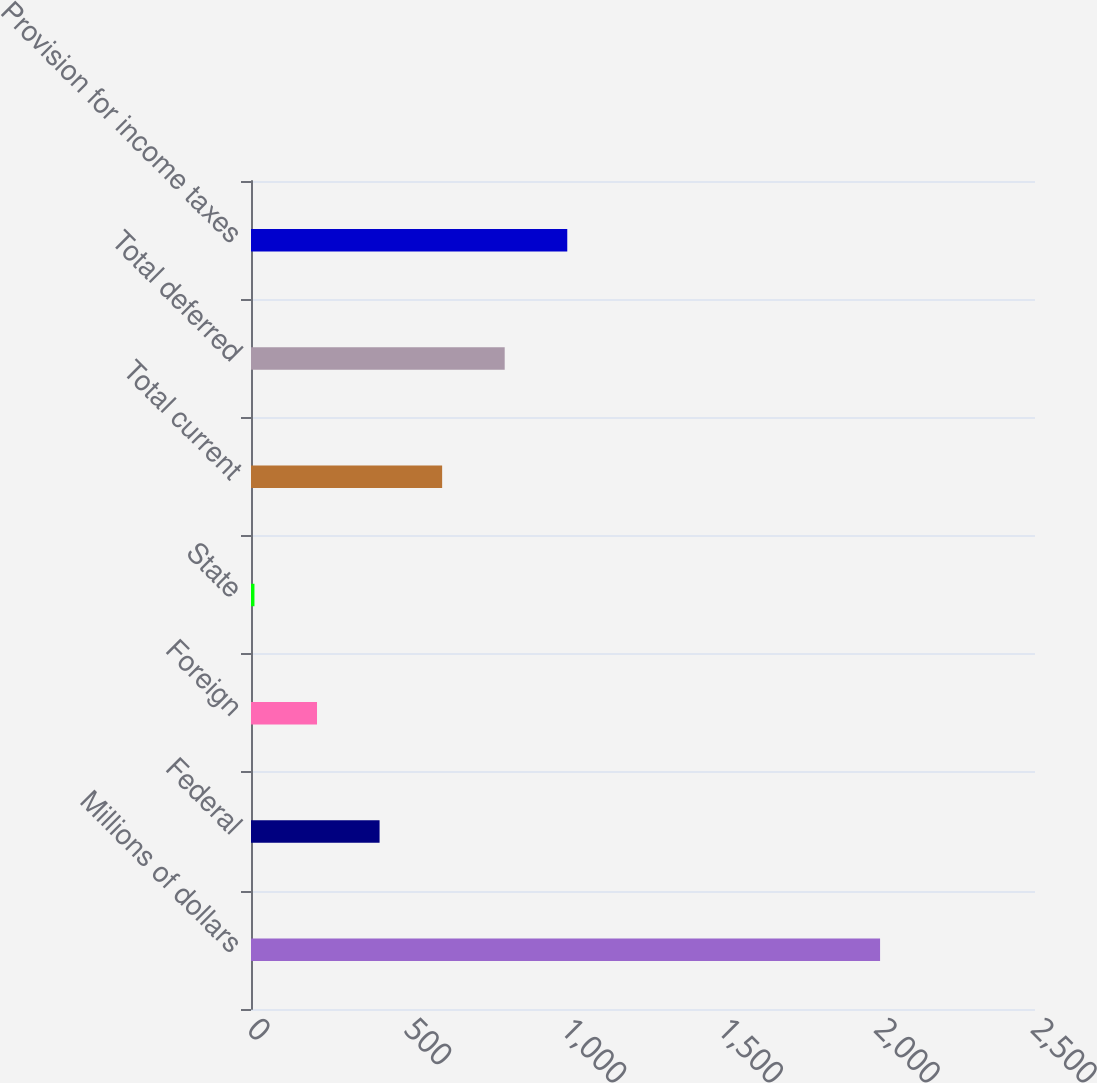<chart> <loc_0><loc_0><loc_500><loc_500><bar_chart><fcel>Millions of dollars<fcel>Federal<fcel>Foreign<fcel>State<fcel>Total current<fcel>Total deferred<fcel>Provision for income taxes<nl><fcel>2006<fcel>410<fcel>210.5<fcel>11<fcel>609.5<fcel>809<fcel>1008.5<nl></chart> 